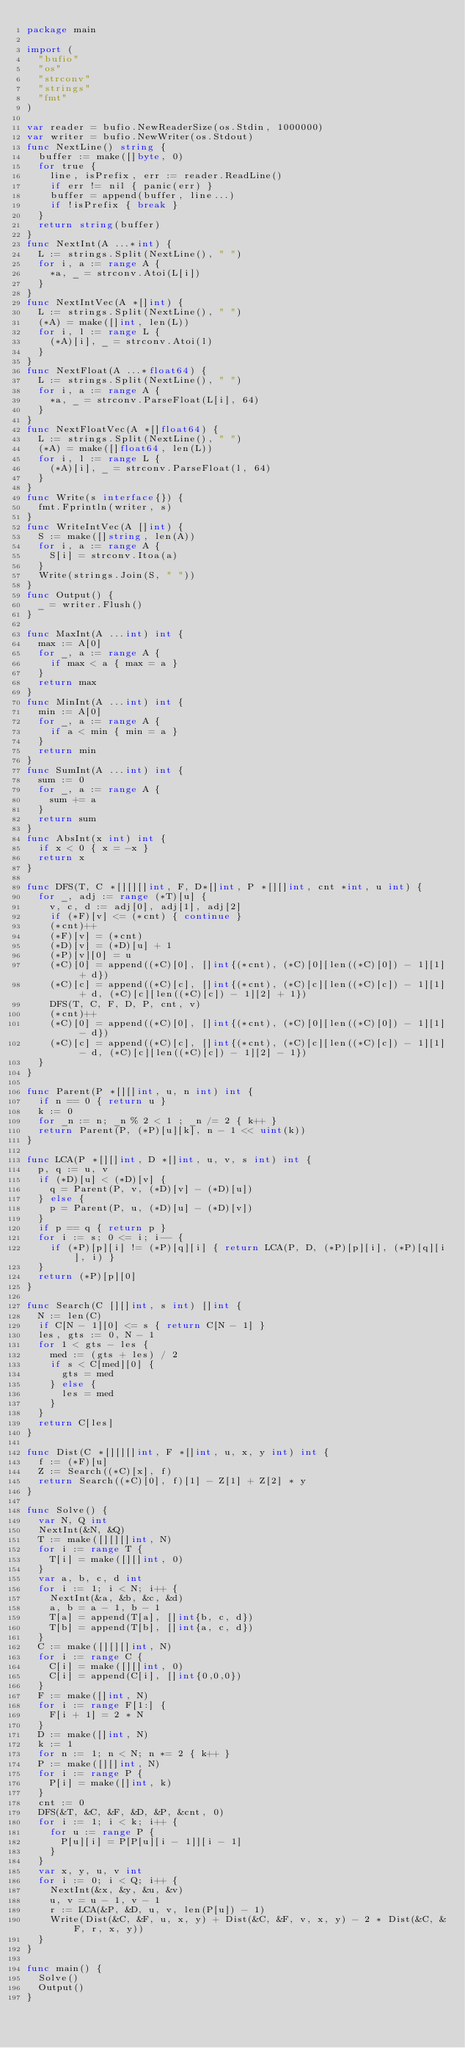Convert code to text. <code><loc_0><loc_0><loc_500><loc_500><_Go_>package main

import (
  "bufio"
  "os"
  "strconv"
  "strings"
  "fmt"
)

var reader = bufio.NewReaderSize(os.Stdin, 1000000)
var writer = bufio.NewWriter(os.Stdout)
func NextLine() string {
  buffer := make([]byte, 0)
  for true {
    line, isPrefix, err := reader.ReadLine()
    if err != nil { panic(err) }
    buffer = append(buffer, line...)
    if !isPrefix { break }
  }
  return string(buffer)
}
func NextInt(A ...*int) {
  L := strings.Split(NextLine(), " ")
  for i, a := range A {
    *a, _ = strconv.Atoi(L[i])
  }
}
func NextIntVec(A *[]int) {
  L := strings.Split(NextLine(), " ")
  (*A) = make([]int, len(L))
  for i, l := range L {
    (*A)[i], _ = strconv.Atoi(l)
  }
}
func NextFloat(A ...*float64) {
  L := strings.Split(NextLine(), " ")
  for i, a := range A {
    *a, _ = strconv.ParseFloat(L[i], 64)
  }
}
func NextFloatVec(A *[]float64) {
  L := strings.Split(NextLine(), " ")
  (*A) = make([]float64, len(L))
  for i, l := range L {
    (*A)[i], _ = strconv.ParseFloat(l, 64)
  }
}
func Write(s interface{}) {
  fmt.Fprintln(writer, s)
}
func WriteIntVec(A []int) {
  S := make([]string, len(A))
  for i, a := range A {
    S[i] = strconv.Itoa(a)
  }
  Write(strings.Join(S, " "))
}
func Output() {
  _ = writer.Flush()
}

func MaxInt(A ...int) int {
  max := A[0]
  for _, a := range A {
    if max < a { max = a }
  }
  return max
}
func MinInt(A ...int) int {
  min := A[0]
  for _, a := range A {
    if a < min { min = a }
  }
  return min
}
func SumInt(A ...int) int {
  sum := 0
  for _, a := range A {
    sum += a
  }
  return sum
}
func AbsInt(x int) int {
  if x < 0 { x = -x }
  return x
}

func DFS(T, C *[][][]int, F, D*[]int, P *[][]int, cnt *int, u int) {
  for _, adj := range (*T)[u] {
    v, c, d := adj[0], adj[1], adj[2]
    if (*F)[v] <= (*cnt) { continue }
    (*cnt)++
    (*F)[v] = (*cnt)
    (*D)[v] = (*D)[u] + 1
    (*P)[v][0] = u
    (*C)[0] = append((*C)[0], []int{(*cnt), (*C)[0][len((*C)[0]) - 1][1] + d})
    (*C)[c] = append((*C)[c], []int{(*cnt), (*C)[c][len((*C)[c]) - 1][1] + d, (*C)[c][len((*C)[c]) - 1][2] + 1})
    DFS(T, C, F, D, P, cnt, v)
    (*cnt)++
    (*C)[0] = append((*C)[0], []int{(*cnt), (*C)[0][len((*C)[0]) - 1][1] - d})
    (*C)[c] = append((*C)[c], []int{(*cnt), (*C)[c][len((*C)[c]) - 1][1] - d, (*C)[c][len((*C)[c]) - 1][2] - 1})
  }
}

func Parent(P *[][]int, u, n int) int {
  if n == 0 { return u }
  k := 0
  for _n := n; _n % 2 < 1 ; _n /= 2 { k++ }
  return Parent(P, (*P)[u][k], n - 1 << uint(k))
}

func LCA(P *[][]int, D *[]int, u, v, s int) int {
  p, q := u, v
  if (*D)[u] < (*D)[v] {
    q = Parent(P, v, (*D)[v] - (*D)[u])
  } else {
    p = Parent(P, u, (*D)[u] - (*D)[v])
  }
  if p == q { return p }
  for i := s; 0 <= i; i-- {
    if (*P)[p][i] != (*P)[q][i] { return LCA(P, D, (*P)[p][i], (*P)[q][i], i) }
  }
  return (*P)[p][0]
}

func Search(C [][]int, s int) []int {
  N := len(C)
  if C[N - 1][0] <= s { return C[N - 1] }
  les, gts := 0, N - 1
  for 1 < gts - les {
    med := (gts + les) / 2
    if s < C[med][0] {
      gts = med
    } else {
      les = med
    }
  }
  return C[les]
}

func Dist(C *[][][]int, F *[]int, u, x, y int) int {
  f := (*F)[u]
  Z := Search((*C)[x], f)
  return Search((*C)[0], f)[1] - Z[1] + Z[2] * y
}

func Solve() {
  var N, Q int
  NextInt(&N, &Q)
  T := make([][][]int, N)
  for i := range T {
    T[i] = make([][]int, 0)
  }
  var a, b, c, d int
  for i := 1; i < N; i++ {
    NextInt(&a, &b, &c, &d)
    a, b = a - 1, b - 1
    T[a] = append(T[a], []int{b, c, d})
    T[b] = append(T[b], []int{a, c, d})
  }
  C := make([][][]int, N)
  for i := range C {
    C[i] = make([][]int, 0)
    C[i] = append(C[i], []int{0,0,0})
  }
  F := make([]int, N)
  for i := range F[1:] {
    F[i + 1] = 2 * N
  }
  D := make([]int, N)
  k := 1
  for n := 1; n < N; n *= 2 { k++ }
  P := make([][]int, N)
  for i := range P {
    P[i] = make([]int, k)
  }
  cnt := 0
  DFS(&T, &C, &F, &D, &P, &cnt, 0)
  for i := 1; i < k; i++ {
    for u := range P {
      P[u][i] = P[P[u][i - 1]][i - 1]
    }
  }
  var x, y, u, v int
  for i := 0; i < Q; i++ {
    NextInt(&x, &y, &u, &v)
    u, v = u - 1, v - 1
    r := LCA(&P, &D, u, v, len(P[u]) - 1)
    Write(Dist(&C, &F, u, x, y) + Dist(&C, &F, v, x, y) - 2 * Dist(&C, &F, r, x, y))
  }
}

func main() {
  Solve()
  Output()
}</code> 